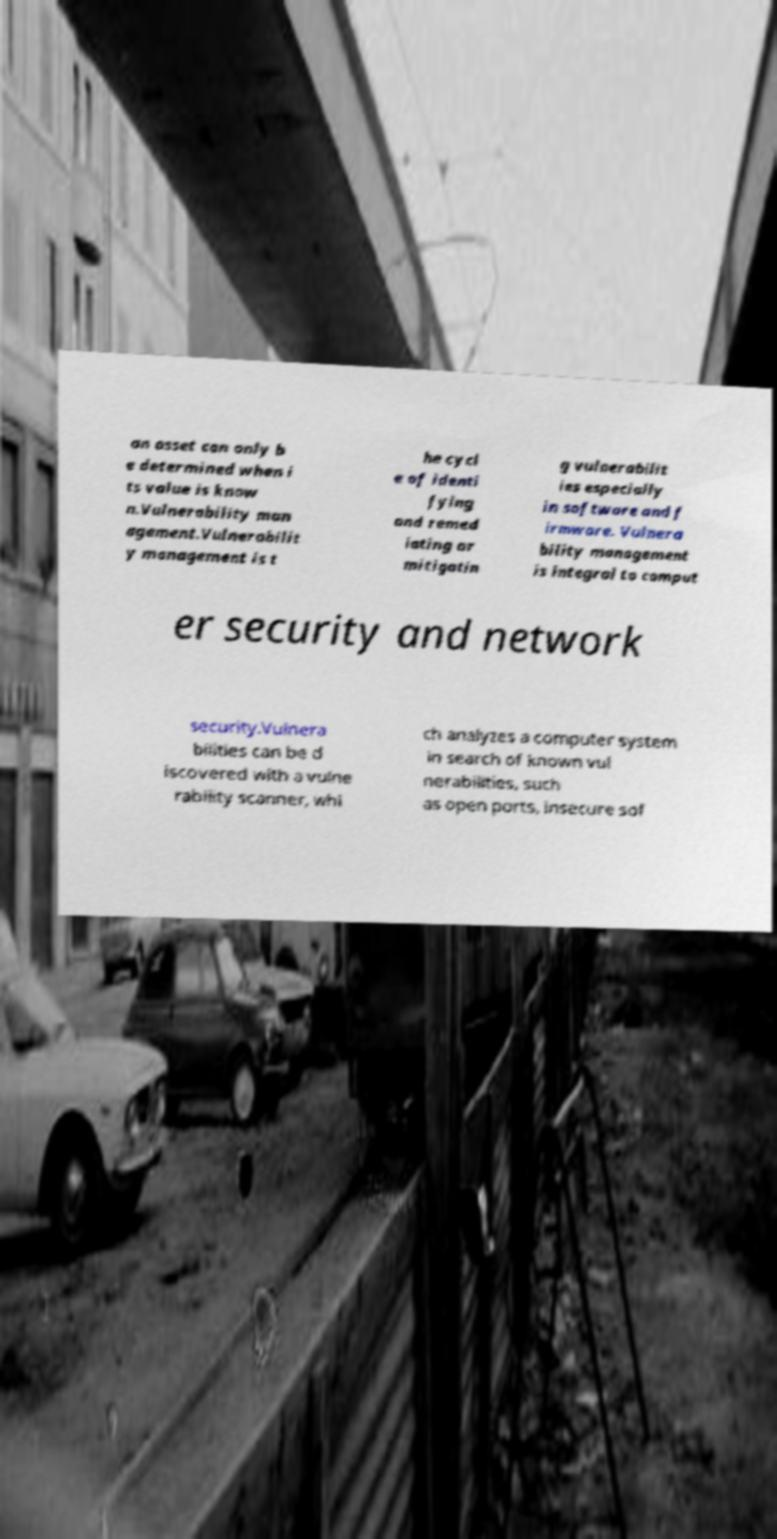Could you extract and type out the text from this image? an asset can only b e determined when i ts value is know n.Vulnerability man agement.Vulnerabilit y management is t he cycl e of identi fying and remed iating or mitigatin g vulnerabilit ies especially in software and f irmware. Vulnera bility management is integral to comput er security and network security.Vulnera bilities can be d iscovered with a vulne rability scanner, whi ch analyzes a computer system in search of known vul nerabilities, such as open ports, insecure sof 